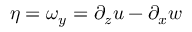<formula> <loc_0><loc_0><loc_500><loc_500>\eta = \omega _ { y } = \partial _ { z } u - \partial _ { x } w</formula> 